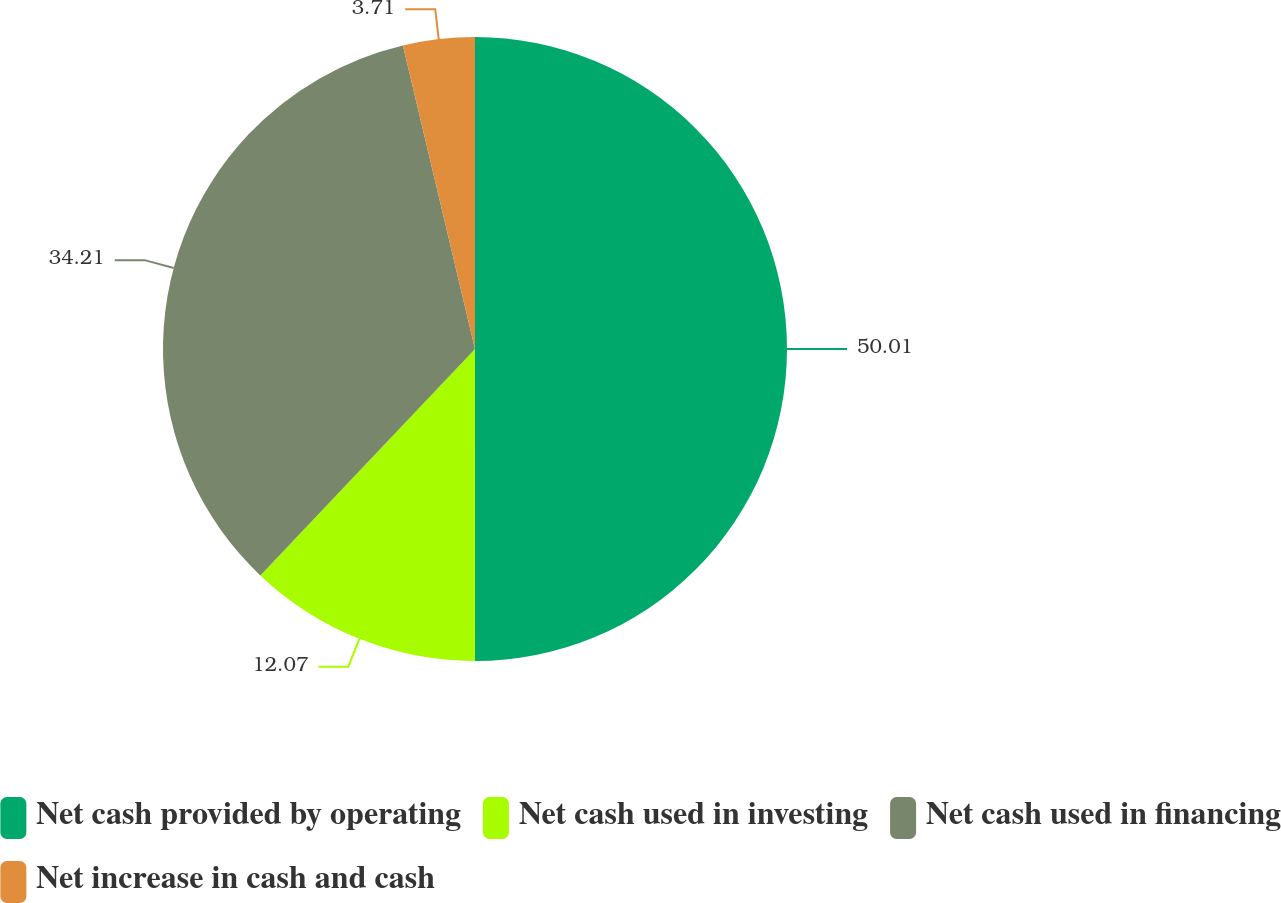Convert chart. <chart><loc_0><loc_0><loc_500><loc_500><pie_chart><fcel>Net cash provided by operating<fcel>Net cash used in investing<fcel>Net cash used in financing<fcel>Net increase in cash and cash<nl><fcel>50.0%<fcel>12.07%<fcel>34.21%<fcel>3.71%<nl></chart> 